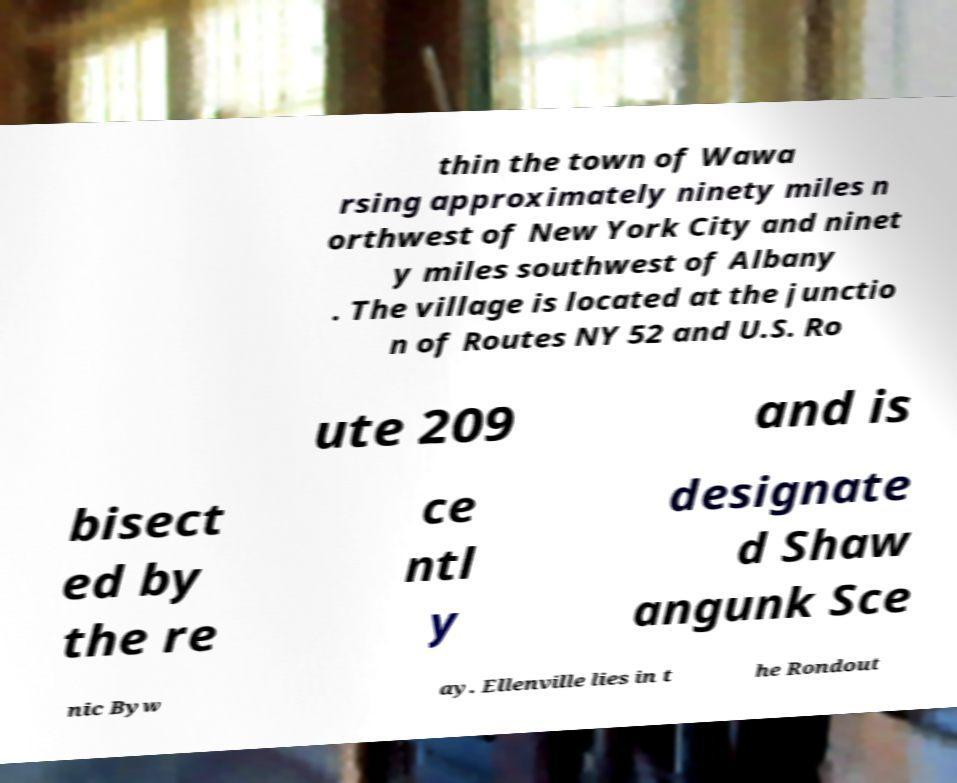There's text embedded in this image that I need extracted. Can you transcribe it verbatim? thin the town of Wawa rsing approximately ninety miles n orthwest of New York City and ninet y miles southwest of Albany . The village is located at the junctio n of Routes NY 52 and U.S. Ro ute 209 and is bisect ed by the re ce ntl y designate d Shaw angunk Sce nic Byw ay. Ellenville lies in t he Rondout 